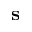Convert formula to latex. <formula><loc_0><loc_0><loc_500><loc_500>s</formula> 